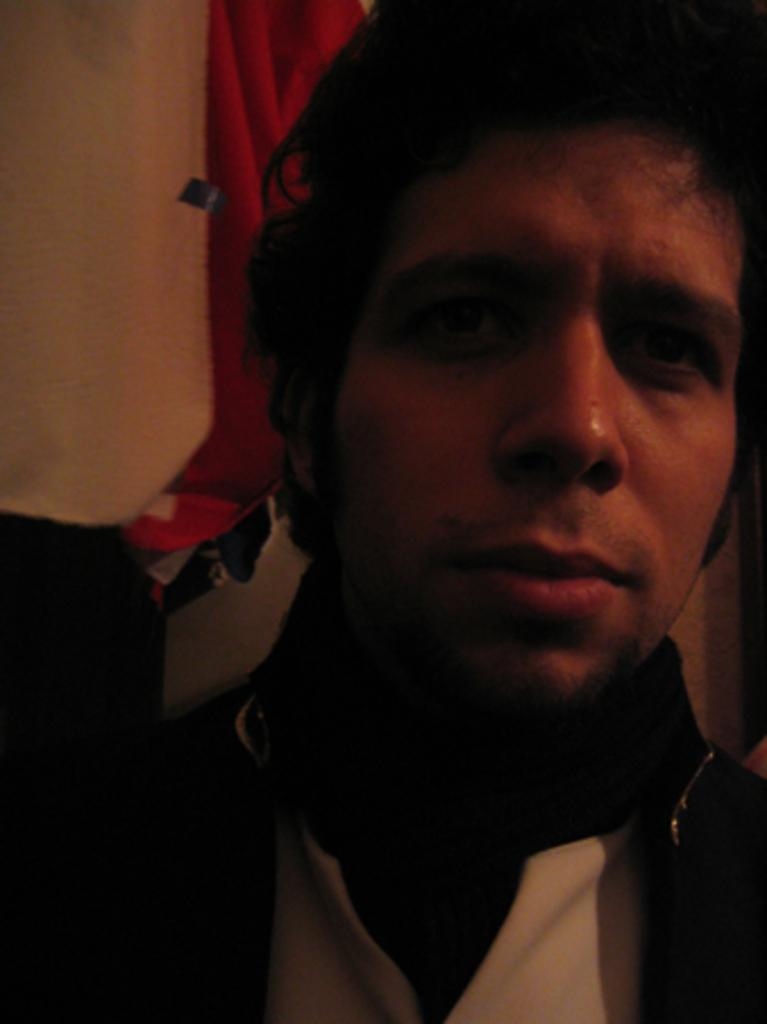Who is present in the image? There is a man in the image. What is the man doing in the image? The man appears to be standing in the image. What can be seen in the background of the image? There are unspecified items in the background of the image. What type of flowers can be seen growing near the station in the image? There is no station or flowers present in the image; it features a man standing with unspecified items in the background. 